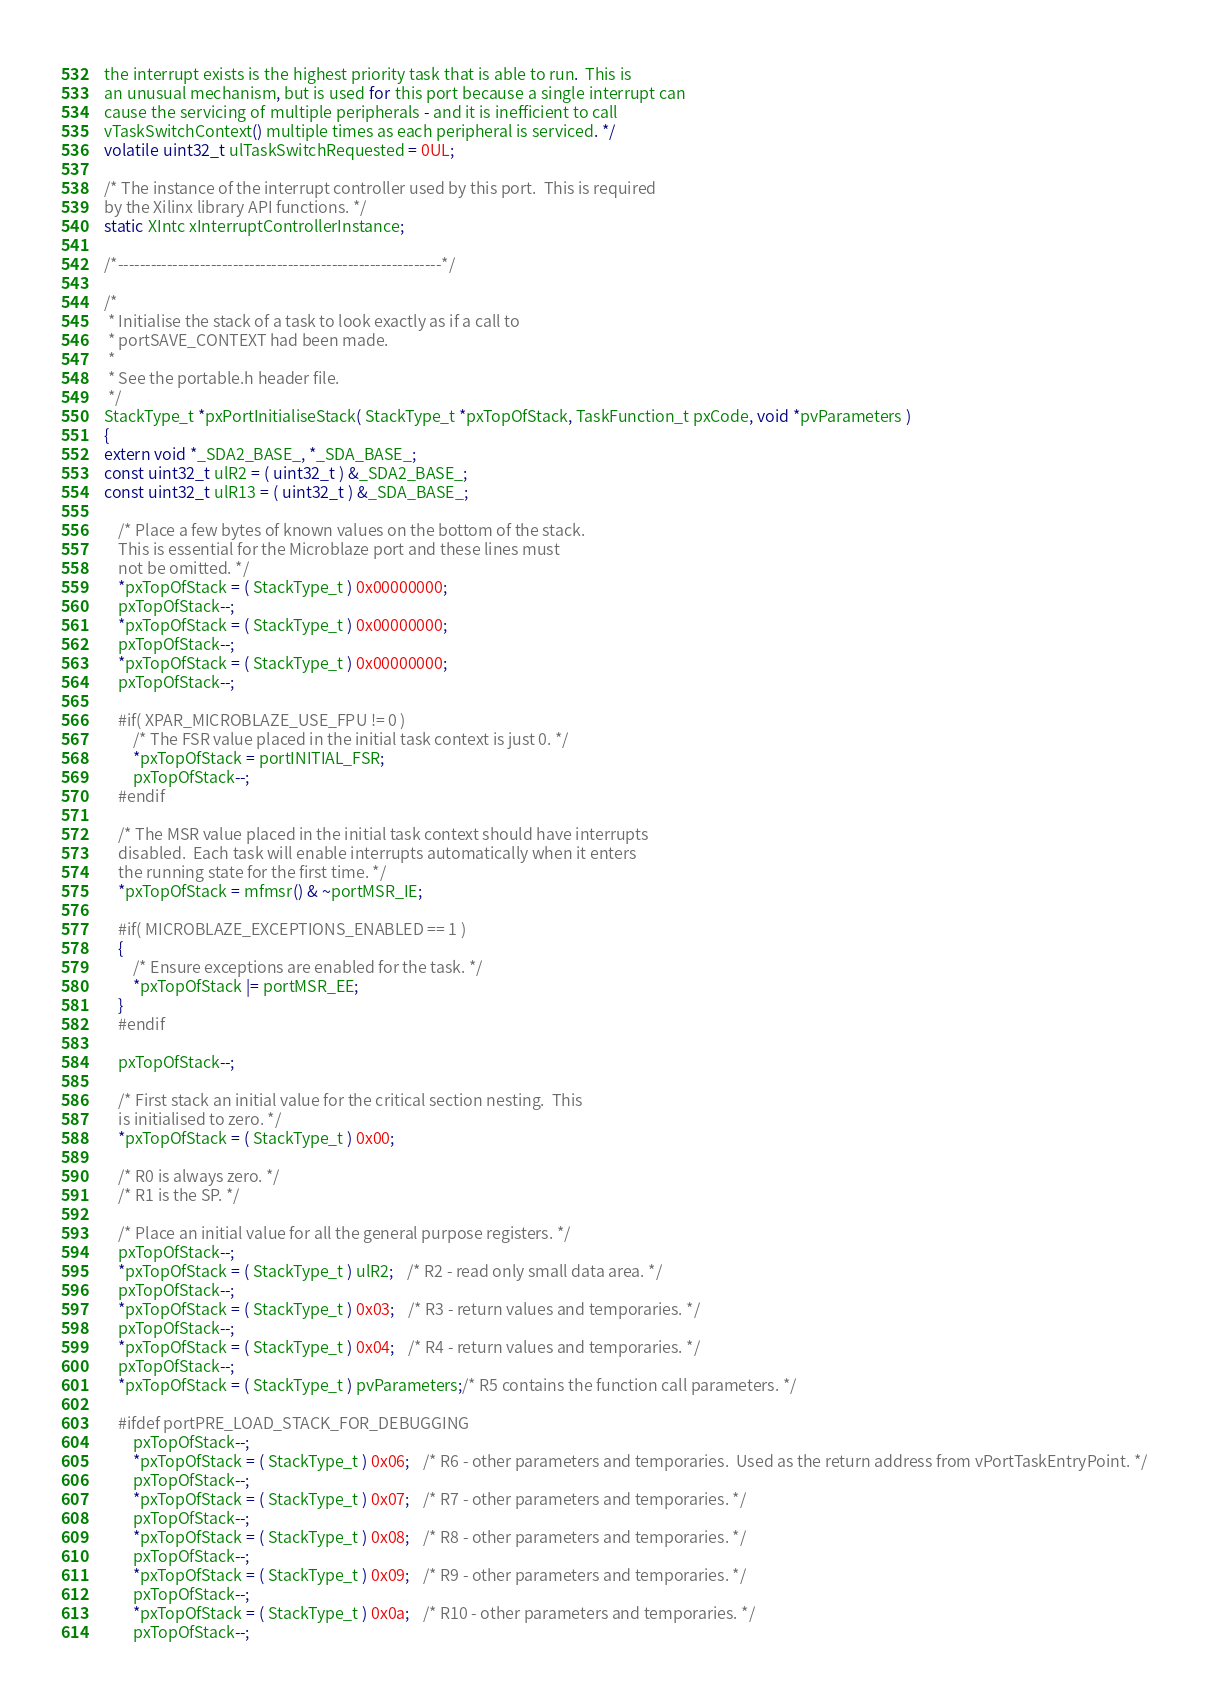Convert code to text. <code><loc_0><loc_0><loc_500><loc_500><_C_>the interrupt exists is the highest priority task that is able to run.  This is
an unusual mechanism, but is used for this port because a single interrupt can
cause the servicing of multiple peripherals - and it is inefficient to call
vTaskSwitchContext() multiple times as each peripheral is serviced. */
volatile uint32_t ulTaskSwitchRequested = 0UL;

/* The instance of the interrupt controller used by this port.  This is required
by the Xilinx library API functions. */
static XIntc xInterruptControllerInstance;

/*-----------------------------------------------------------*/

/*
 * Initialise the stack of a task to look exactly as if a call to
 * portSAVE_CONTEXT had been made.
 *
 * See the portable.h header file.
 */
StackType_t *pxPortInitialiseStack( StackType_t *pxTopOfStack, TaskFunction_t pxCode, void *pvParameters )
{
extern void *_SDA2_BASE_, *_SDA_BASE_;
const uint32_t ulR2 = ( uint32_t ) &_SDA2_BASE_;
const uint32_t ulR13 = ( uint32_t ) &_SDA_BASE_;

	/* Place a few bytes of known values on the bottom of the stack.
	This is essential for the Microblaze port and these lines must
	not be omitted. */
	*pxTopOfStack = ( StackType_t ) 0x00000000;
	pxTopOfStack--;
	*pxTopOfStack = ( StackType_t ) 0x00000000;
	pxTopOfStack--;
	*pxTopOfStack = ( StackType_t ) 0x00000000;
	pxTopOfStack--;

	#if( XPAR_MICROBLAZE_USE_FPU != 0 )
		/* The FSR value placed in the initial task context is just 0. */
		*pxTopOfStack = portINITIAL_FSR;
		pxTopOfStack--;
	#endif

	/* The MSR value placed in the initial task context should have interrupts
	disabled.  Each task will enable interrupts automatically when it enters
	the running state for the first time. */
	*pxTopOfStack = mfmsr() & ~portMSR_IE;
	
	#if( MICROBLAZE_EXCEPTIONS_ENABLED == 1 )
	{
		/* Ensure exceptions are enabled for the task. */
		*pxTopOfStack |= portMSR_EE;
	}
	#endif

	pxTopOfStack--;

	/* First stack an initial value for the critical section nesting.  This
	is initialised to zero. */
	*pxTopOfStack = ( StackType_t ) 0x00;

	/* R0 is always zero. */
	/* R1 is the SP. */

	/* Place an initial value for all the general purpose registers. */
	pxTopOfStack--;
	*pxTopOfStack = ( StackType_t ) ulR2;	/* R2 - read only small data area. */
	pxTopOfStack--;
	*pxTopOfStack = ( StackType_t ) 0x03;	/* R3 - return values and temporaries. */
	pxTopOfStack--;
	*pxTopOfStack = ( StackType_t ) 0x04;	/* R4 - return values and temporaries. */
	pxTopOfStack--;
	*pxTopOfStack = ( StackType_t ) pvParameters;/* R5 contains the function call parameters. */

	#ifdef portPRE_LOAD_STACK_FOR_DEBUGGING
		pxTopOfStack--;
		*pxTopOfStack = ( StackType_t ) 0x06;	/* R6 - other parameters and temporaries.  Used as the return address from vPortTaskEntryPoint. */
		pxTopOfStack--;
		*pxTopOfStack = ( StackType_t ) 0x07;	/* R7 - other parameters and temporaries. */
		pxTopOfStack--;
		*pxTopOfStack = ( StackType_t ) 0x08;	/* R8 - other parameters and temporaries. */
		pxTopOfStack--;
		*pxTopOfStack = ( StackType_t ) 0x09;	/* R9 - other parameters and temporaries. */
		pxTopOfStack--;
		*pxTopOfStack = ( StackType_t ) 0x0a;	/* R10 - other parameters and temporaries. */
		pxTopOfStack--;</code> 